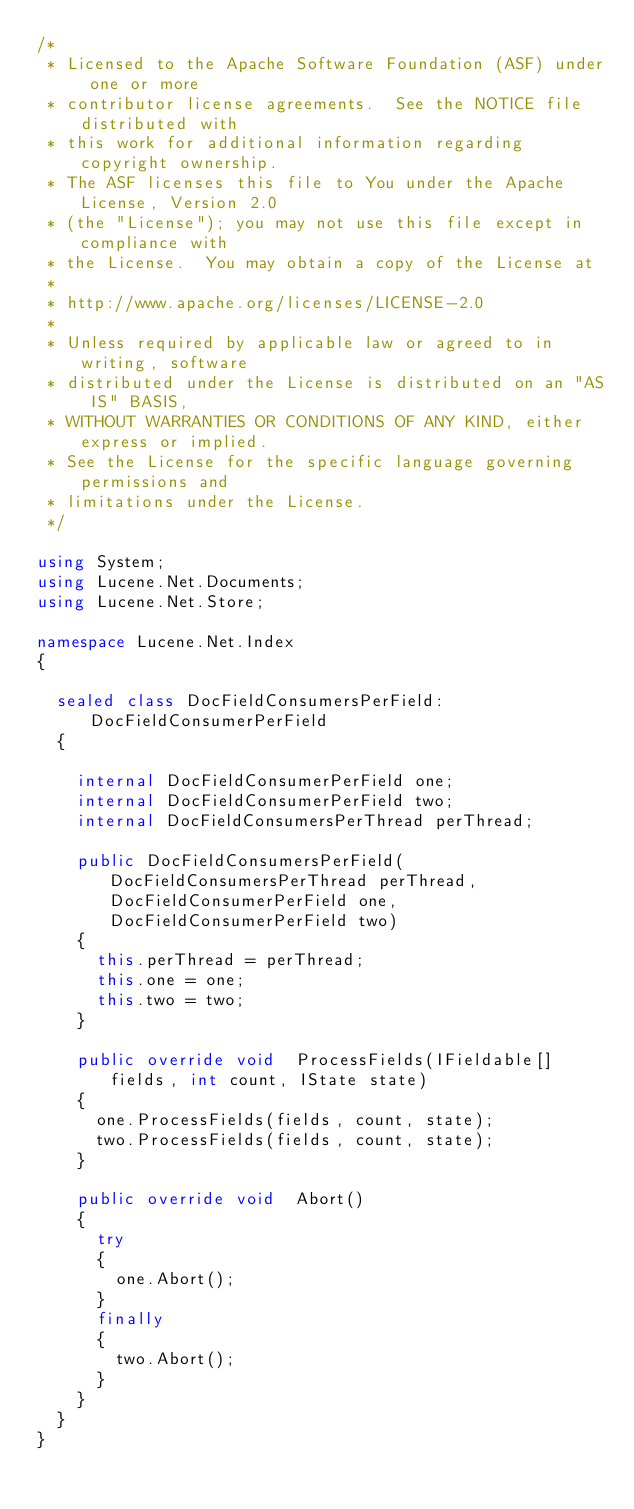<code> <loc_0><loc_0><loc_500><loc_500><_C#_>/* 
 * Licensed to the Apache Software Foundation (ASF) under one or more
 * contributor license agreements.  See the NOTICE file distributed with
 * this work for additional information regarding copyright ownership.
 * The ASF licenses this file to You under the Apache License, Version 2.0
 * (the "License"); you may not use this file except in compliance with
 * the License.  You may obtain a copy of the License at
 * 
 * http://www.apache.org/licenses/LICENSE-2.0
 * 
 * Unless required by applicable law or agreed to in writing, software
 * distributed under the License is distributed on an "AS IS" BASIS,
 * WITHOUT WARRANTIES OR CONDITIONS OF ANY KIND, either express or implied.
 * See the License for the specific language governing permissions and
 * limitations under the License.
 */

using System;
using Lucene.Net.Documents;
using Lucene.Net.Store;

namespace Lucene.Net.Index
{
	
	sealed class DocFieldConsumersPerField:DocFieldConsumerPerField
	{
		
		internal DocFieldConsumerPerField one;
		internal DocFieldConsumerPerField two;
		internal DocFieldConsumersPerThread perThread;
		
		public DocFieldConsumersPerField(DocFieldConsumersPerThread perThread, DocFieldConsumerPerField one, DocFieldConsumerPerField two)
		{
			this.perThread = perThread;
			this.one = one;
			this.two = two;
		}
		
		public override void  ProcessFields(IFieldable[] fields, int count, IState state)
		{
			one.ProcessFields(fields, count, state);
			two.ProcessFields(fields, count, state);
		}
		
		public override void  Abort()
		{
			try
			{
				one.Abort();
			}
			finally
			{
				two.Abort();
			}
		}
	}
}</code> 